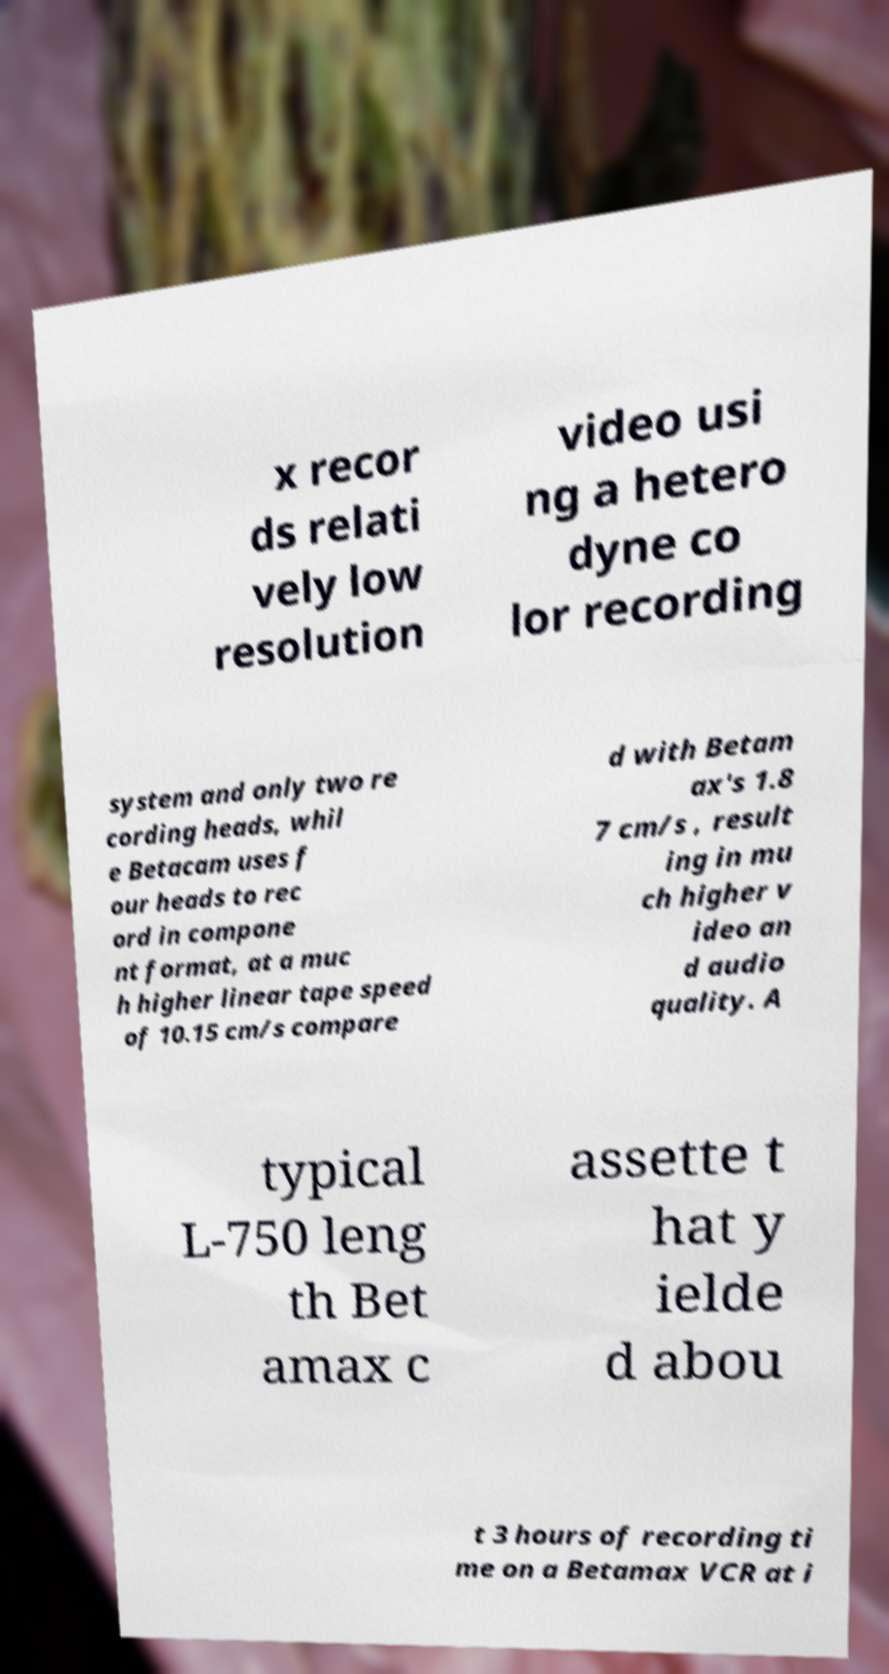What messages or text are displayed in this image? I need them in a readable, typed format. x recor ds relati vely low resolution video usi ng a hetero dyne co lor recording system and only two re cording heads, whil e Betacam uses f our heads to rec ord in compone nt format, at a muc h higher linear tape speed of 10.15 cm/s compare d with Betam ax's 1.8 7 cm/s , result ing in mu ch higher v ideo an d audio quality. A typical L-750 leng th Bet amax c assette t hat y ielde d abou t 3 hours of recording ti me on a Betamax VCR at i 